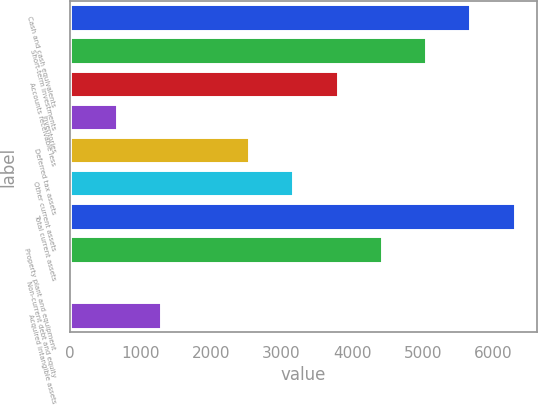Convert chart to OTSL. <chart><loc_0><loc_0><loc_500><loc_500><bar_chart><fcel>Cash and cash equivalents<fcel>Short-term investments<fcel>Accounts receivable less<fcel>Inventories<fcel>Deferred tax assets<fcel>Other current assets<fcel>Total current assets<fcel>Property plant and equipment<fcel>Non-current debt and equity<fcel>Acquired intangible assets<nl><fcel>5672.1<fcel>5046.2<fcel>3794.4<fcel>664.9<fcel>2542.6<fcel>3168.5<fcel>6298<fcel>4420.3<fcel>39<fcel>1290.8<nl></chart> 